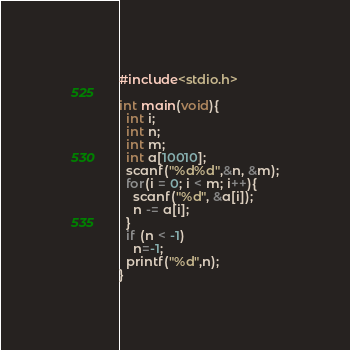Convert code to text. <code><loc_0><loc_0><loc_500><loc_500><_C_>#include<stdio.h>
 
int main(void){
  int i;
  int n;
  int m;
  int a[10010];
  scanf("%d%d",&n, &m);
  for(i = 0; i < m; i++){
    scanf("%d", &a[i]);
    n -= a[i];
  }
  if (n < -1)
    n=-1;
  printf("%d",n);
}</code> 